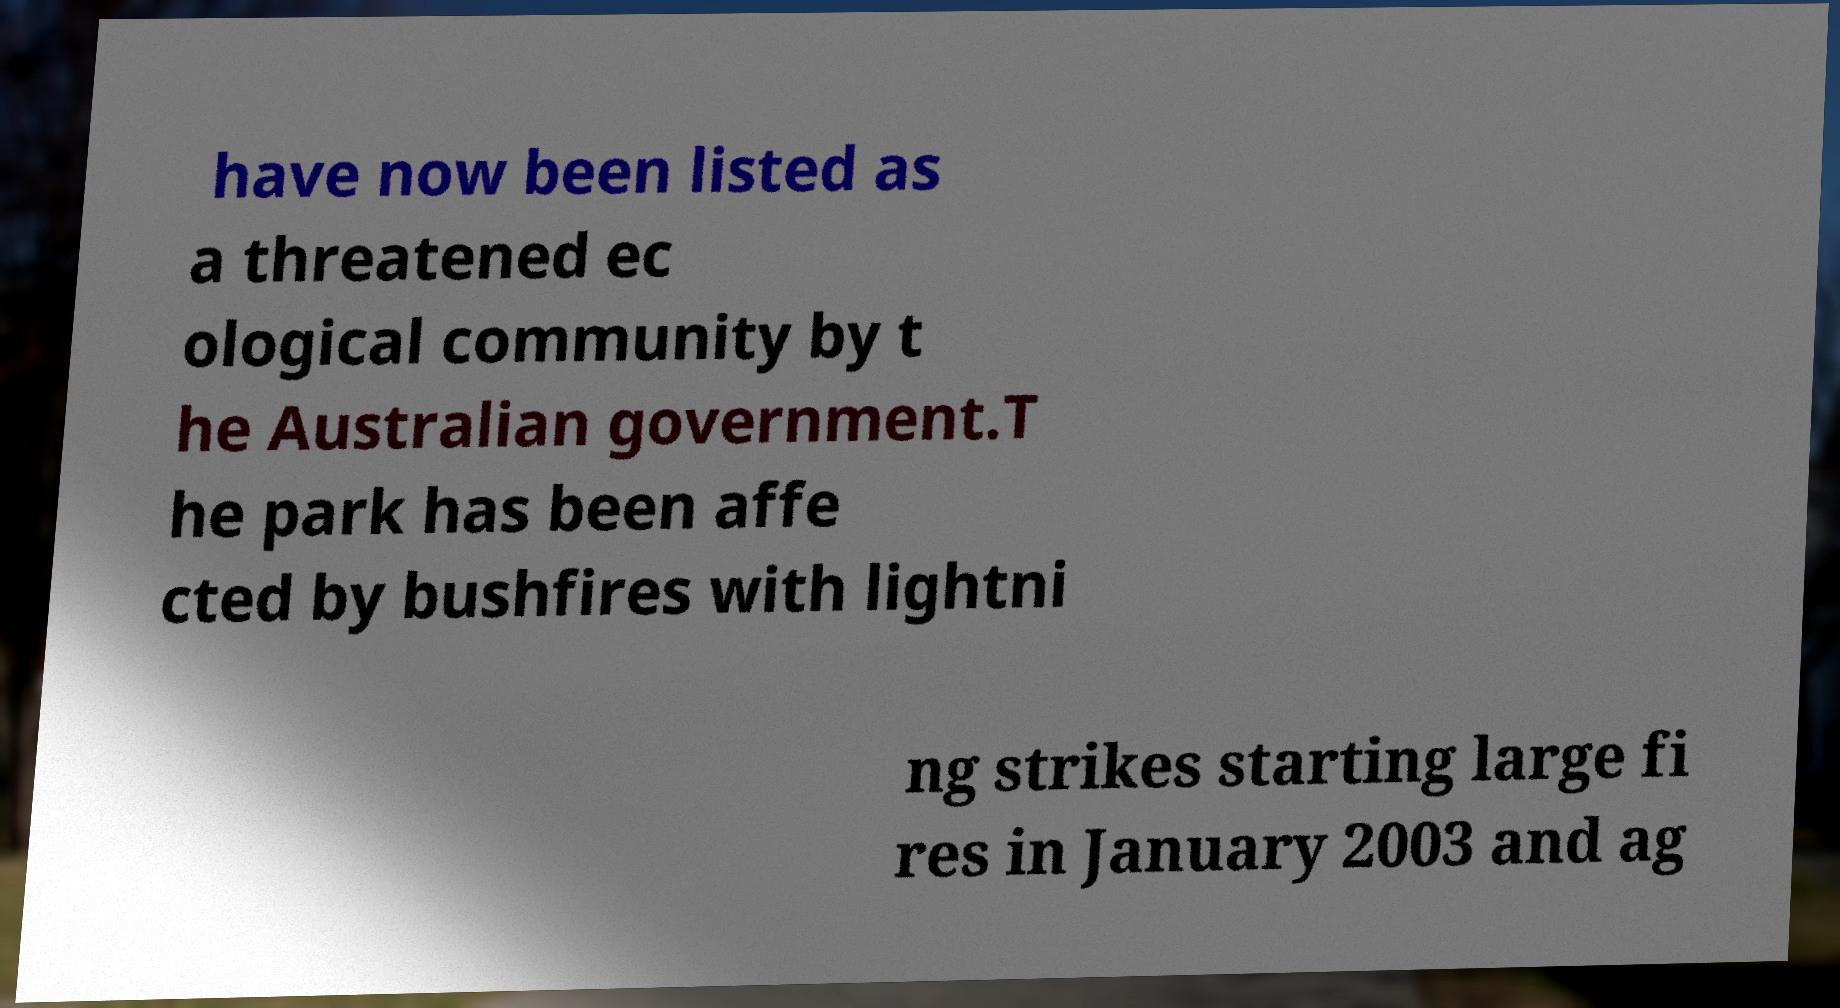I need the written content from this picture converted into text. Can you do that? have now been listed as a threatened ec ological community by t he Australian government.T he park has been affe cted by bushfires with lightni ng strikes starting large fi res in January 2003 and ag 